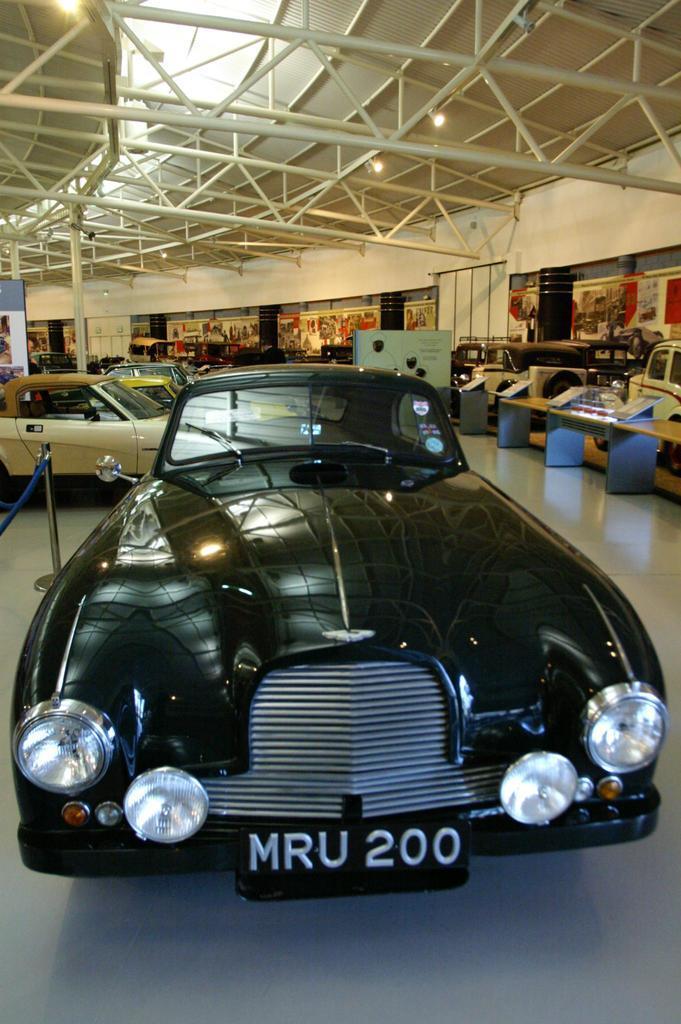Could you give a brief overview of what you see in this image? In this image there is a black color car, rope barrier, and in the background there are cars, boards , table, iron rods, lights. 